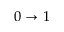<formula> <loc_0><loc_0><loc_500><loc_500>0 \rightarrow 1</formula> 